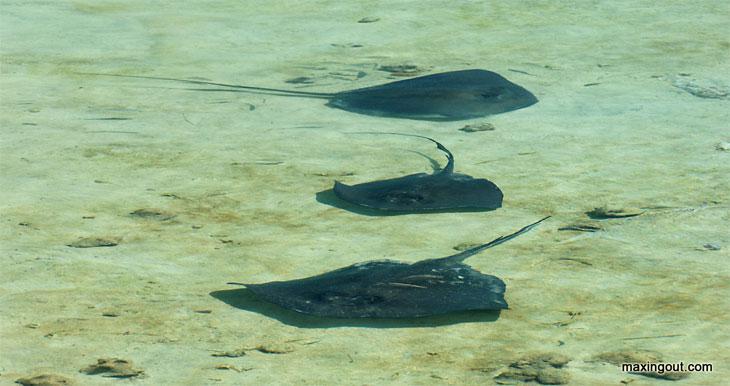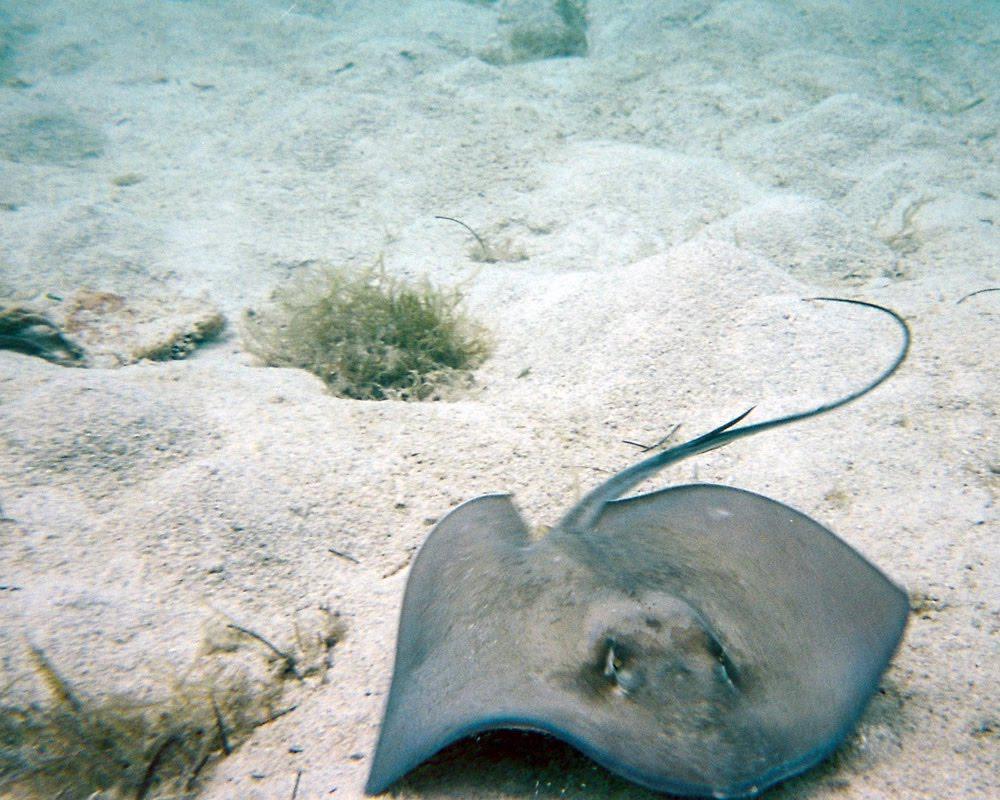The first image is the image on the left, the second image is the image on the right. Examine the images to the left and right. Is the description "A woman in a bikini is in the water next to a gray stingray." accurate? Answer yes or no. No. The first image is the image on the left, the second image is the image on the right. Considering the images on both sides, is "The woman in the left image is wearing a bikini; we can clearly see most of her bathing suit." valid? Answer yes or no. No. 